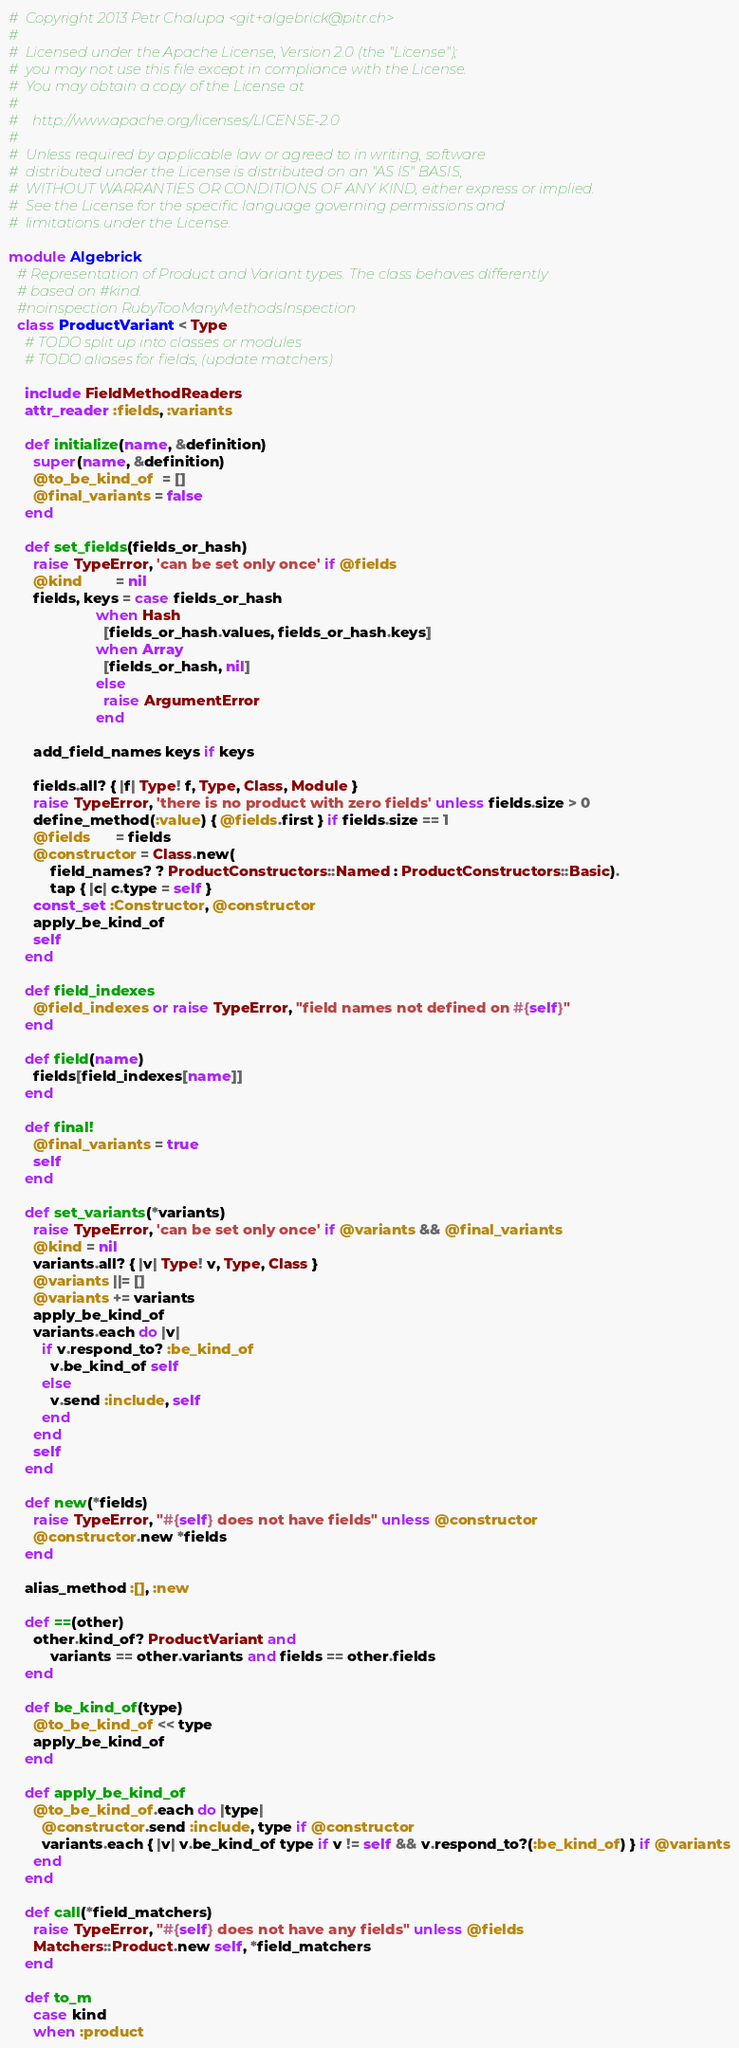Convert code to text. <code><loc_0><loc_0><loc_500><loc_500><_Ruby_>#  Copyright 2013 Petr Chalupa <git+algebrick@pitr.ch>
#
#  Licensed under the Apache License, Version 2.0 (the "License");
#  you may not use this file except in compliance with the License.
#  You may obtain a copy of the License at
#
#    http://www.apache.org/licenses/LICENSE-2.0
#
#  Unless required by applicable law or agreed to in writing, software
#  distributed under the License is distributed on an "AS IS" BASIS,
#  WITHOUT WARRANTIES OR CONDITIONS OF ANY KIND, either express or implied.
#  See the License for the specific language governing permissions and
#  limitations under the License.

module Algebrick
  # Representation of Product and Variant types. The class behaves differently
  # based on #kind.
  #noinspection RubyTooManyMethodsInspection
  class ProductVariant < Type
    # TODO split up into classes or modules
    # TODO aliases for fields, (update matchers)

    include FieldMethodReaders
    attr_reader :fields, :variants

    def initialize(name, &definition)
      super(name, &definition)
      @to_be_kind_of  = []
      @final_variants = false
    end

    def set_fields(fields_or_hash)
      raise TypeError, 'can be set only once' if @fields
      @kind        = nil
      fields, keys = case fields_or_hash
                     when Hash
                       [fields_or_hash.values, fields_or_hash.keys]
                     when Array
                       [fields_or_hash, nil]
                     else
                       raise ArgumentError
                     end

      add_field_names keys if keys

      fields.all? { |f| Type! f, Type, Class, Module }
      raise TypeError, 'there is no product with zero fields' unless fields.size > 0
      define_method(:value) { @fields.first } if fields.size == 1
      @fields      = fields
      @constructor = Class.new(
          field_names? ? ProductConstructors::Named : ProductConstructors::Basic).
          tap { |c| c.type = self }
      const_set :Constructor, @constructor
      apply_be_kind_of
      self
    end

    def field_indexes
      @field_indexes or raise TypeError, "field names not defined on #{self}"
    end

    def field(name)
      fields[field_indexes[name]]
    end

    def final!
      @final_variants = true
      self
    end

    def set_variants(*variants)
      raise TypeError, 'can be set only once' if @variants && @final_variants
      @kind = nil
      variants.all? { |v| Type! v, Type, Class }
      @variants ||= []
      @variants += variants
      apply_be_kind_of
      variants.each do |v|
        if v.respond_to? :be_kind_of
          v.be_kind_of self
        else
          v.send :include, self
        end
      end
      self
    end

    def new(*fields)
      raise TypeError, "#{self} does not have fields" unless @constructor
      @constructor.new *fields
    end

    alias_method :[], :new

    def ==(other)
      other.kind_of? ProductVariant and
          variants == other.variants and fields == other.fields
    end

    def be_kind_of(type)
      @to_be_kind_of << type
      apply_be_kind_of
    end

    def apply_be_kind_of
      @to_be_kind_of.each do |type|
        @constructor.send :include, type if @constructor
        variants.each { |v| v.be_kind_of type if v != self && v.respond_to?(:be_kind_of) } if @variants
      end
    end

    def call(*field_matchers)
      raise TypeError, "#{self} does not have any fields" unless @fields
      Matchers::Product.new self, *field_matchers
    end

    def to_m
      case kind
      when :product</code> 